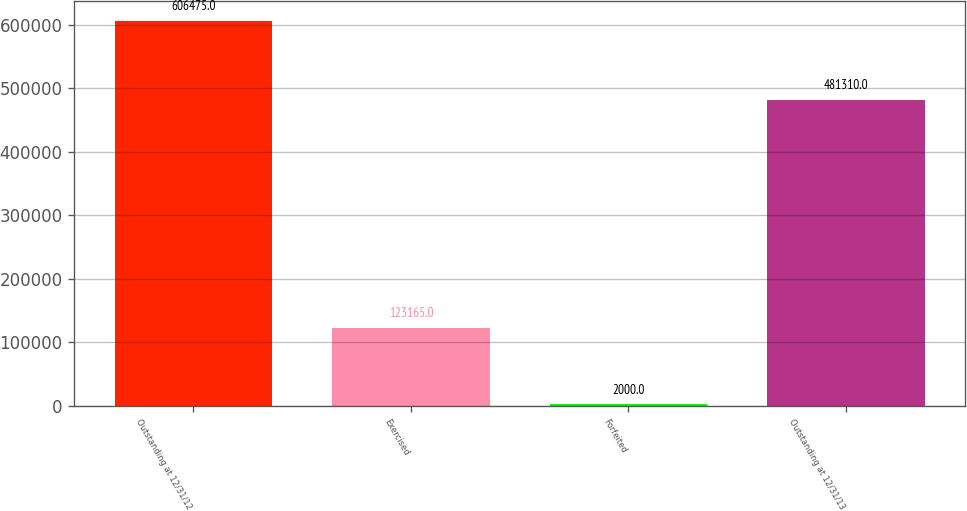<chart> <loc_0><loc_0><loc_500><loc_500><bar_chart><fcel>Outstanding at 12/31/12<fcel>Exercised<fcel>Forfeited<fcel>Outstanding at 12/31/13<nl><fcel>606475<fcel>123165<fcel>2000<fcel>481310<nl></chart> 